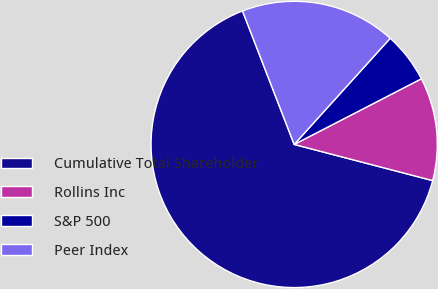Convert chart. <chart><loc_0><loc_0><loc_500><loc_500><pie_chart><fcel>Cumulative Total Shareholder<fcel>Rollins Inc<fcel>S&P 500<fcel>Peer Index<nl><fcel>65.05%<fcel>11.65%<fcel>5.71%<fcel>17.58%<nl></chart> 